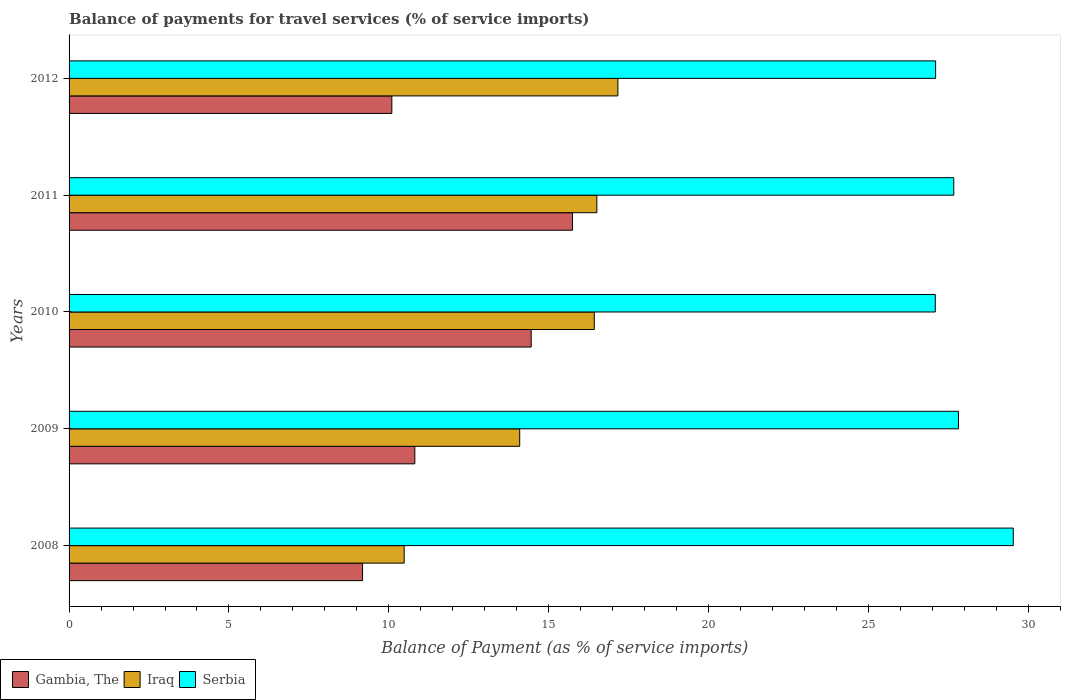How many different coloured bars are there?
Offer a terse response. 3. How many groups of bars are there?
Keep it short and to the point. 5. Are the number of bars per tick equal to the number of legend labels?
Offer a terse response. Yes. Are the number of bars on each tick of the Y-axis equal?
Make the answer very short. Yes. How many bars are there on the 4th tick from the bottom?
Ensure brevity in your answer.  3. What is the label of the 4th group of bars from the top?
Keep it short and to the point. 2009. In how many cases, is the number of bars for a given year not equal to the number of legend labels?
Provide a short and direct response. 0. What is the balance of payments for travel services in Gambia, The in 2009?
Offer a very short reply. 10.81. Across all years, what is the maximum balance of payments for travel services in Serbia?
Keep it short and to the point. 29.53. Across all years, what is the minimum balance of payments for travel services in Serbia?
Keep it short and to the point. 27.09. In which year was the balance of payments for travel services in Serbia maximum?
Make the answer very short. 2008. What is the total balance of payments for travel services in Gambia, The in the graph?
Provide a short and direct response. 60.28. What is the difference between the balance of payments for travel services in Serbia in 2011 and that in 2012?
Give a very brief answer. 0.57. What is the difference between the balance of payments for travel services in Iraq in 2009 and the balance of payments for travel services in Gambia, The in 2012?
Make the answer very short. 4. What is the average balance of payments for travel services in Serbia per year?
Your answer should be very brief. 27.84. In the year 2009, what is the difference between the balance of payments for travel services in Iraq and balance of payments for travel services in Gambia, The?
Offer a terse response. 3.28. In how many years, is the balance of payments for travel services in Gambia, The greater than 8 %?
Give a very brief answer. 5. What is the ratio of the balance of payments for travel services in Iraq in 2009 to that in 2011?
Give a very brief answer. 0.85. Is the difference between the balance of payments for travel services in Iraq in 2010 and 2011 greater than the difference between the balance of payments for travel services in Gambia, The in 2010 and 2011?
Give a very brief answer. Yes. What is the difference between the highest and the second highest balance of payments for travel services in Gambia, The?
Offer a terse response. 1.29. What is the difference between the highest and the lowest balance of payments for travel services in Gambia, The?
Provide a succinct answer. 6.57. In how many years, is the balance of payments for travel services in Gambia, The greater than the average balance of payments for travel services in Gambia, The taken over all years?
Provide a succinct answer. 2. What does the 2nd bar from the top in 2008 represents?
Provide a succinct answer. Iraq. What does the 2nd bar from the bottom in 2009 represents?
Offer a terse response. Iraq. Is it the case that in every year, the sum of the balance of payments for travel services in Gambia, The and balance of payments for travel services in Iraq is greater than the balance of payments for travel services in Serbia?
Your response must be concise. No. How many bars are there?
Your response must be concise. 15. What is the difference between two consecutive major ticks on the X-axis?
Offer a terse response. 5. Are the values on the major ticks of X-axis written in scientific E-notation?
Offer a very short reply. No. Does the graph contain any zero values?
Keep it short and to the point. No. Where does the legend appear in the graph?
Provide a succinct answer. Bottom left. How are the legend labels stacked?
Your response must be concise. Horizontal. What is the title of the graph?
Provide a short and direct response. Balance of payments for travel services (% of service imports). What is the label or title of the X-axis?
Provide a short and direct response. Balance of Payment (as % of service imports). What is the label or title of the Y-axis?
Your answer should be compact. Years. What is the Balance of Payment (as % of service imports) of Gambia, The in 2008?
Offer a terse response. 9.18. What is the Balance of Payment (as % of service imports) of Iraq in 2008?
Provide a short and direct response. 10.48. What is the Balance of Payment (as % of service imports) in Serbia in 2008?
Make the answer very short. 29.53. What is the Balance of Payment (as % of service imports) in Gambia, The in 2009?
Provide a short and direct response. 10.81. What is the Balance of Payment (as % of service imports) of Iraq in 2009?
Offer a very short reply. 14.09. What is the Balance of Payment (as % of service imports) of Serbia in 2009?
Provide a succinct answer. 27.81. What is the Balance of Payment (as % of service imports) in Gambia, The in 2010?
Provide a short and direct response. 14.45. What is the Balance of Payment (as % of service imports) of Iraq in 2010?
Offer a terse response. 16.42. What is the Balance of Payment (as % of service imports) in Serbia in 2010?
Make the answer very short. 27.09. What is the Balance of Payment (as % of service imports) in Gambia, The in 2011?
Provide a short and direct response. 15.74. What is the Balance of Payment (as % of service imports) in Iraq in 2011?
Offer a very short reply. 16.5. What is the Balance of Payment (as % of service imports) of Serbia in 2011?
Offer a very short reply. 27.67. What is the Balance of Payment (as % of service imports) in Gambia, The in 2012?
Offer a very short reply. 10.09. What is the Balance of Payment (as % of service imports) of Iraq in 2012?
Offer a very short reply. 17.16. What is the Balance of Payment (as % of service imports) of Serbia in 2012?
Your answer should be very brief. 27.1. Across all years, what is the maximum Balance of Payment (as % of service imports) in Gambia, The?
Provide a succinct answer. 15.74. Across all years, what is the maximum Balance of Payment (as % of service imports) in Iraq?
Offer a terse response. 17.16. Across all years, what is the maximum Balance of Payment (as % of service imports) of Serbia?
Offer a terse response. 29.53. Across all years, what is the minimum Balance of Payment (as % of service imports) of Gambia, The?
Your response must be concise. 9.18. Across all years, what is the minimum Balance of Payment (as % of service imports) in Iraq?
Offer a terse response. 10.48. Across all years, what is the minimum Balance of Payment (as % of service imports) of Serbia?
Keep it short and to the point. 27.09. What is the total Balance of Payment (as % of service imports) of Gambia, The in the graph?
Provide a short and direct response. 60.28. What is the total Balance of Payment (as % of service imports) in Iraq in the graph?
Offer a terse response. 74.66. What is the total Balance of Payment (as % of service imports) in Serbia in the graph?
Make the answer very short. 139.19. What is the difference between the Balance of Payment (as % of service imports) in Gambia, The in 2008 and that in 2009?
Your response must be concise. -1.64. What is the difference between the Balance of Payment (as % of service imports) of Iraq in 2008 and that in 2009?
Your answer should be compact. -3.61. What is the difference between the Balance of Payment (as % of service imports) of Serbia in 2008 and that in 2009?
Your response must be concise. 1.71. What is the difference between the Balance of Payment (as % of service imports) in Gambia, The in 2008 and that in 2010?
Keep it short and to the point. -5.27. What is the difference between the Balance of Payment (as % of service imports) of Iraq in 2008 and that in 2010?
Provide a succinct answer. -5.94. What is the difference between the Balance of Payment (as % of service imports) of Serbia in 2008 and that in 2010?
Provide a succinct answer. 2.44. What is the difference between the Balance of Payment (as % of service imports) in Gambia, The in 2008 and that in 2011?
Ensure brevity in your answer.  -6.57. What is the difference between the Balance of Payment (as % of service imports) of Iraq in 2008 and that in 2011?
Your answer should be compact. -6.03. What is the difference between the Balance of Payment (as % of service imports) of Serbia in 2008 and that in 2011?
Keep it short and to the point. 1.86. What is the difference between the Balance of Payment (as % of service imports) in Gambia, The in 2008 and that in 2012?
Offer a very short reply. -0.92. What is the difference between the Balance of Payment (as % of service imports) in Iraq in 2008 and that in 2012?
Your answer should be compact. -6.68. What is the difference between the Balance of Payment (as % of service imports) of Serbia in 2008 and that in 2012?
Offer a very short reply. 2.43. What is the difference between the Balance of Payment (as % of service imports) in Gambia, The in 2009 and that in 2010?
Ensure brevity in your answer.  -3.64. What is the difference between the Balance of Payment (as % of service imports) of Iraq in 2009 and that in 2010?
Ensure brevity in your answer.  -2.33. What is the difference between the Balance of Payment (as % of service imports) in Serbia in 2009 and that in 2010?
Keep it short and to the point. 0.73. What is the difference between the Balance of Payment (as % of service imports) of Gambia, The in 2009 and that in 2011?
Offer a terse response. -4.93. What is the difference between the Balance of Payment (as % of service imports) in Iraq in 2009 and that in 2011?
Keep it short and to the point. -2.41. What is the difference between the Balance of Payment (as % of service imports) in Serbia in 2009 and that in 2011?
Your answer should be very brief. 0.15. What is the difference between the Balance of Payment (as % of service imports) in Gambia, The in 2009 and that in 2012?
Offer a very short reply. 0.72. What is the difference between the Balance of Payment (as % of service imports) in Iraq in 2009 and that in 2012?
Keep it short and to the point. -3.07. What is the difference between the Balance of Payment (as % of service imports) in Serbia in 2009 and that in 2012?
Your response must be concise. 0.71. What is the difference between the Balance of Payment (as % of service imports) in Gambia, The in 2010 and that in 2011?
Your answer should be very brief. -1.29. What is the difference between the Balance of Payment (as % of service imports) in Iraq in 2010 and that in 2011?
Offer a terse response. -0.08. What is the difference between the Balance of Payment (as % of service imports) in Serbia in 2010 and that in 2011?
Your answer should be compact. -0.58. What is the difference between the Balance of Payment (as % of service imports) in Gambia, The in 2010 and that in 2012?
Ensure brevity in your answer.  4.36. What is the difference between the Balance of Payment (as % of service imports) of Iraq in 2010 and that in 2012?
Provide a short and direct response. -0.74. What is the difference between the Balance of Payment (as % of service imports) in Serbia in 2010 and that in 2012?
Make the answer very short. -0.01. What is the difference between the Balance of Payment (as % of service imports) of Gambia, The in 2011 and that in 2012?
Offer a terse response. 5.65. What is the difference between the Balance of Payment (as % of service imports) of Iraq in 2011 and that in 2012?
Give a very brief answer. -0.66. What is the difference between the Balance of Payment (as % of service imports) of Serbia in 2011 and that in 2012?
Offer a very short reply. 0.57. What is the difference between the Balance of Payment (as % of service imports) in Gambia, The in 2008 and the Balance of Payment (as % of service imports) in Iraq in 2009?
Your answer should be compact. -4.91. What is the difference between the Balance of Payment (as % of service imports) in Gambia, The in 2008 and the Balance of Payment (as % of service imports) in Serbia in 2009?
Make the answer very short. -18.64. What is the difference between the Balance of Payment (as % of service imports) of Iraq in 2008 and the Balance of Payment (as % of service imports) of Serbia in 2009?
Offer a terse response. -17.33. What is the difference between the Balance of Payment (as % of service imports) in Gambia, The in 2008 and the Balance of Payment (as % of service imports) in Iraq in 2010?
Ensure brevity in your answer.  -7.25. What is the difference between the Balance of Payment (as % of service imports) of Gambia, The in 2008 and the Balance of Payment (as % of service imports) of Serbia in 2010?
Offer a terse response. -17.91. What is the difference between the Balance of Payment (as % of service imports) of Iraq in 2008 and the Balance of Payment (as % of service imports) of Serbia in 2010?
Your answer should be very brief. -16.61. What is the difference between the Balance of Payment (as % of service imports) of Gambia, The in 2008 and the Balance of Payment (as % of service imports) of Iraq in 2011?
Offer a terse response. -7.33. What is the difference between the Balance of Payment (as % of service imports) of Gambia, The in 2008 and the Balance of Payment (as % of service imports) of Serbia in 2011?
Provide a succinct answer. -18.49. What is the difference between the Balance of Payment (as % of service imports) of Iraq in 2008 and the Balance of Payment (as % of service imports) of Serbia in 2011?
Make the answer very short. -17.19. What is the difference between the Balance of Payment (as % of service imports) in Gambia, The in 2008 and the Balance of Payment (as % of service imports) in Iraq in 2012?
Offer a very short reply. -7.98. What is the difference between the Balance of Payment (as % of service imports) of Gambia, The in 2008 and the Balance of Payment (as % of service imports) of Serbia in 2012?
Keep it short and to the point. -17.92. What is the difference between the Balance of Payment (as % of service imports) of Iraq in 2008 and the Balance of Payment (as % of service imports) of Serbia in 2012?
Give a very brief answer. -16.62. What is the difference between the Balance of Payment (as % of service imports) of Gambia, The in 2009 and the Balance of Payment (as % of service imports) of Iraq in 2010?
Give a very brief answer. -5.61. What is the difference between the Balance of Payment (as % of service imports) of Gambia, The in 2009 and the Balance of Payment (as % of service imports) of Serbia in 2010?
Provide a succinct answer. -16.28. What is the difference between the Balance of Payment (as % of service imports) of Iraq in 2009 and the Balance of Payment (as % of service imports) of Serbia in 2010?
Your answer should be compact. -13. What is the difference between the Balance of Payment (as % of service imports) of Gambia, The in 2009 and the Balance of Payment (as % of service imports) of Iraq in 2011?
Ensure brevity in your answer.  -5.69. What is the difference between the Balance of Payment (as % of service imports) of Gambia, The in 2009 and the Balance of Payment (as % of service imports) of Serbia in 2011?
Offer a terse response. -16.85. What is the difference between the Balance of Payment (as % of service imports) of Iraq in 2009 and the Balance of Payment (as % of service imports) of Serbia in 2011?
Your response must be concise. -13.57. What is the difference between the Balance of Payment (as % of service imports) in Gambia, The in 2009 and the Balance of Payment (as % of service imports) in Iraq in 2012?
Provide a succinct answer. -6.35. What is the difference between the Balance of Payment (as % of service imports) of Gambia, The in 2009 and the Balance of Payment (as % of service imports) of Serbia in 2012?
Provide a short and direct response. -16.29. What is the difference between the Balance of Payment (as % of service imports) of Iraq in 2009 and the Balance of Payment (as % of service imports) of Serbia in 2012?
Offer a very short reply. -13.01. What is the difference between the Balance of Payment (as % of service imports) in Gambia, The in 2010 and the Balance of Payment (as % of service imports) in Iraq in 2011?
Your answer should be very brief. -2.05. What is the difference between the Balance of Payment (as % of service imports) in Gambia, The in 2010 and the Balance of Payment (as % of service imports) in Serbia in 2011?
Your response must be concise. -13.21. What is the difference between the Balance of Payment (as % of service imports) in Iraq in 2010 and the Balance of Payment (as % of service imports) in Serbia in 2011?
Ensure brevity in your answer.  -11.24. What is the difference between the Balance of Payment (as % of service imports) in Gambia, The in 2010 and the Balance of Payment (as % of service imports) in Iraq in 2012?
Give a very brief answer. -2.71. What is the difference between the Balance of Payment (as % of service imports) in Gambia, The in 2010 and the Balance of Payment (as % of service imports) in Serbia in 2012?
Your response must be concise. -12.65. What is the difference between the Balance of Payment (as % of service imports) of Iraq in 2010 and the Balance of Payment (as % of service imports) of Serbia in 2012?
Your answer should be compact. -10.67. What is the difference between the Balance of Payment (as % of service imports) in Gambia, The in 2011 and the Balance of Payment (as % of service imports) in Iraq in 2012?
Provide a succinct answer. -1.42. What is the difference between the Balance of Payment (as % of service imports) of Gambia, The in 2011 and the Balance of Payment (as % of service imports) of Serbia in 2012?
Give a very brief answer. -11.36. What is the difference between the Balance of Payment (as % of service imports) of Iraq in 2011 and the Balance of Payment (as % of service imports) of Serbia in 2012?
Keep it short and to the point. -10.59. What is the average Balance of Payment (as % of service imports) in Gambia, The per year?
Give a very brief answer. 12.06. What is the average Balance of Payment (as % of service imports) of Iraq per year?
Offer a very short reply. 14.93. What is the average Balance of Payment (as % of service imports) of Serbia per year?
Offer a terse response. 27.84. In the year 2008, what is the difference between the Balance of Payment (as % of service imports) of Gambia, The and Balance of Payment (as % of service imports) of Iraq?
Provide a succinct answer. -1.3. In the year 2008, what is the difference between the Balance of Payment (as % of service imports) in Gambia, The and Balance of Payment (as % of service imports) in Serbia?
Keep it short and to the point. -20.35. In the year 2008, what is the difference between the Balance of Payment (as % of service imports) of Iraq and Balance of Payment (as % of service imports) of Serbia?
Keep it short and to the point. -19.05. In the year 2009, what is the difference between the Balance of Payment (as % of service imports) in Gambia, The and Balance of Payment (as % of service imports) in Iraq?
Keep it short and to the point. -3.28. In the year 2009, what is the difference between the Balance of Payment (as % of service imports) of Gambia, The and Balance of Payment (as % of service imports) of Serbia?
Provide a short and direct response. -17. In the year 2009, what is the difference between the Balance of Payment (as % of service imports) of Iraq and Balance of Payment (as % of service imports) of Serbia?
Your answer should be very brief. -13.72. In the year 2010, what is the difference between the Balance of Payment (as % of service imports) in Gambia, The and Balance of Payment (as % of service imports) in Iraq?
Offer a very short reply. -1.97. In the year 2010, what is the difference between the Balance of Payment (as % of service imports) in Gambia, The and Balance of Payment (as % of service imports) in Serbia?
Offer a very short reply. -12.64. In the year 2010, what is the difference between the Balance of Payment (as % of service imports) of Iraq and Balance of Payment (as % of service imports) of Serbia?
Your response must be concise. -10.66. In the year 2011, what is the difference between the Balance of Payment (as % of service imports) of Gambia, The and Balance of Payment (as % of service imports) of Iraq?
Keep it short and to the point. -0.76. In the year 2011, what is the difference between the Balance of Payment (as % of service imports) of Gambia, The and Balance of Payment (as % of service imports) of Serbia?
Provide a succinct answer. -11.92. In the year 2011, what is the difference between the Balance of Payment (as % of service imports) in Iraq and Balance of Payment (as % of service imports) in Serbia?
Provide a succinct answer. -11.16. In the year 2012, what is the difference between the Balance of Payment (as % of service imports) in Gambia, The and Balance of Payment (as % of service imports) in Iraq?
Make the answer very short. -7.07. In the year 2012, what is the difference between the Balance of Payment (as % of service imports) in Gambia, The and Balance of Payment (as % of service imports) in Serbia?
Make the answer very short. -17.01. In the year 2012, what is the difference between the Balance of Payment (as % of service imports) in Iraq and Balance of Payment (as % of service imports) in Serbia?
Give a very brief answer. -9.94. What is the ratio of the Balance of Payment (as % of service imports) in Gambia, The in 2008 to that in 2009?
Your response must be concise. 0.85. What is the ratio of the Balance of Payment (as % of service imports) in Iraq in 2008 to that in 2009?
Offer a terse response. 0.74. What is the ratio of the Balance of Payment (as % of service imports) in Serbia in 2008 to that in 2009?
Provide a succinct answer. 1.06. What is the ratio of the Balance of Payment (as % of service imports) of Gambia, The in 2008 to that in 2010?
Make the answer very short. 0.64. What is the ratio of the Balance of Payment (as % of service imports) in Iraq in 2008 to that in 2010?
Your answer should be compact. 0.64. What is the ratio of the Balance of Payment (as % of service imports) of Serbia in 2008 to that in 2010?
Give a very brief answer. 1.09. What is the ratio of the Balance of Payment (as % of service imports) of Gambia, The in 2008 to that in 2011?
Ensure brevity in your answer.  0.58. What is the ratio of the Balance of Payment (as % of service imports) in Iraq in 2008 to that in 2011?
Make the answer very short. 0.63. What is the ratio of the Balance of Payment (as % of service imports) of Serbia in 2008 to that in 2011?
Make the answer very short. 1.07. What is the ratio of the Balance of Payment (as % of service imports) in Gambia, The in 2008 to that in 2012?
Your answer should be very brief. 0.91. What is the ratio of the Balance of Payment (as % of service imports) of Iraq in 2008 to that in 2012?
Offer a terse response. 0.61. What is the ratio of the Balance of Payment (as % of service imports) of Serbia in 2008 to that in 2012?
Your response must be concise. 1.09. What is the ratio of the Balance of Payment (as % of service imports) in Gambia, The in 2009 to that in 2010?
Provide a short and direct response. 0.75. What is the ratio of the Balance of Payment (as % of service imports) in Iraq in 2009 to that in 2010?
Keep it short and to the point. 0.86. What is the ratio of the Balance of Payment (as % of service imports) of Serbia in 2009 to that in 2010?
Offer a very short reply. 1.03. What is the ratio of the Balance of Payment (as % of service imports) in Gambia, The in 2009 to that in 2011?
Offer a terse response. 0.69. What is the ratio of the Balance of Payment (as % of service imports) in Iraq in 2009 to that in 2011?
Keep it short and to the point. 0.85. What is the ratio of the Balance of Payment (as % of service imports) in Serbia in 2009 to that in 2011?
Ensure brevity in your answer.  1.01. What is the ratio of the Balance of Payment (as % of service imports) of Gambia, The in 2009 to that in 2012?
Provide a short and direct response. 1.07. What is the ratio of the Balance of Payment (as % of service imports) in Iraq in 2009 to that in 2012?
Provide a short and direct response. 0.82. What is the ratio of the Balance of Payment (as % of service imports) in Serbia in 2009 to that in 2012?
Ensure brevity in your answer.  1.03. What is the ratio of the Balance of Payment (as % of service imports) of Gambia, The in 2010 to that in 2011?
Make the answer very short. 0.92. What is the ratio of the Balance of Payment (as % of service imports) of Iraq in 2010 to that in 2011?
Provide a succinct answer. 1. What is the ratio of the Balance of Payment (as % of service imports) of Serbia in 2010 to that in 2011?
Keep it short and to the point. 0.98. What is the ratio of the Balance of Payment (as % of service imports) of Gambia, The in 2010 to that in 2012?
Offer a terse response. 1.43. What is the ratio of the Balance of Payment (as % of service imports) of Gambia, The in 2011 to that in 2012?
Your answer should be very brief. 1.56. What is the ratio of the Balance of Payment (as % of service imports) of Iraq in 2011 to that in 2012?
Your response must be concise. 0.96. What is the ratio of the Balance of Payment (as % of service imports) of Serbia in 2011 to that in 2012?
Offer a very short reply. 1.02. What is the difference between the highest and the second highest Balance of Payment (as % of service imports) of Gambia, The?
Provide a short and direct response. 1.29. What is the difference between the highest and the second highest Balance of Payment (as % of service imports) of Iraq?
Give a very brief answer. 0.66. What is the difference between the highest and the second highest Balance of Payment (as % of service imports) in Serbia?
Provide a succinct answer. 1.71. What is the difference between the highest and the lowest Balance of Payment (as % of service imports) in Gambia, The?
Ensure brevity in your answer.  6.57. What is the difference between the highest and the lowest Balance of Payment (as % of service imports) of Iraq?
Your response must be concise. 6.68. What is the difference between the highest and the lowest Balance of Payment (as % of service imports) in Serbia?
Keep it short and to the point. 2.44. 